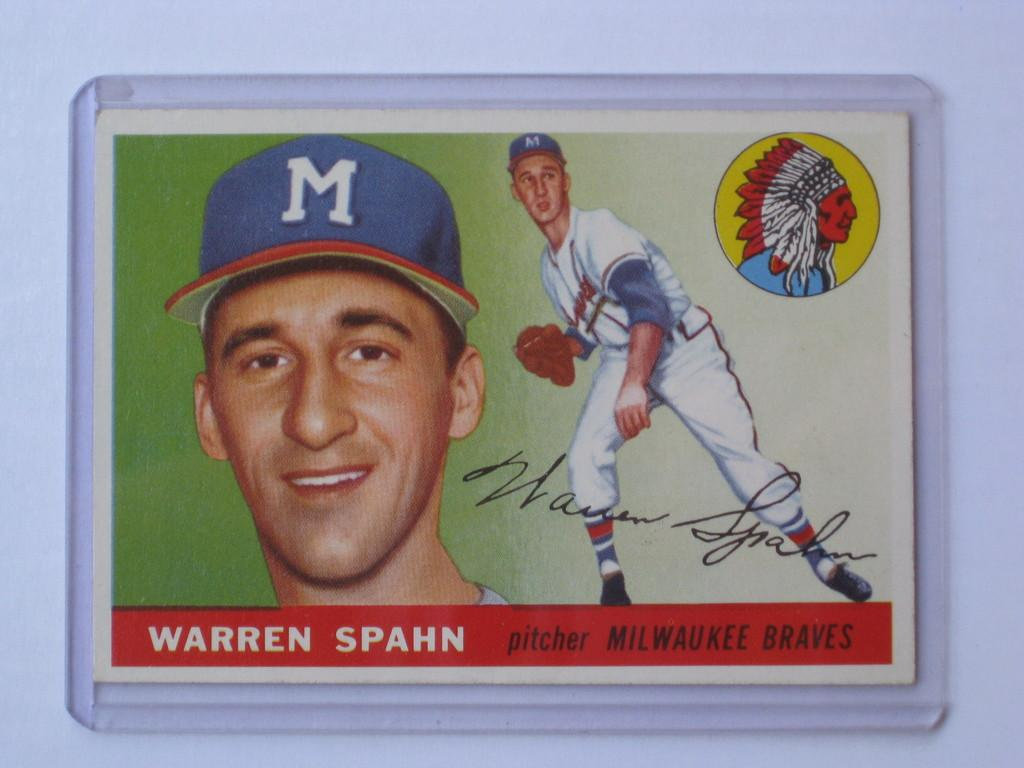What is the main object in the image? There is a board in the image. Is there anyone in the image? Yes, there is a person in the image. What is written on the board? There is writing on the board. What color is the background of the image? The background of the image is white. Can you see the person's father in the image? There is no mention of a father or any other family members in the image. Is there a gate visible in the image? There is no gate present in the image. 